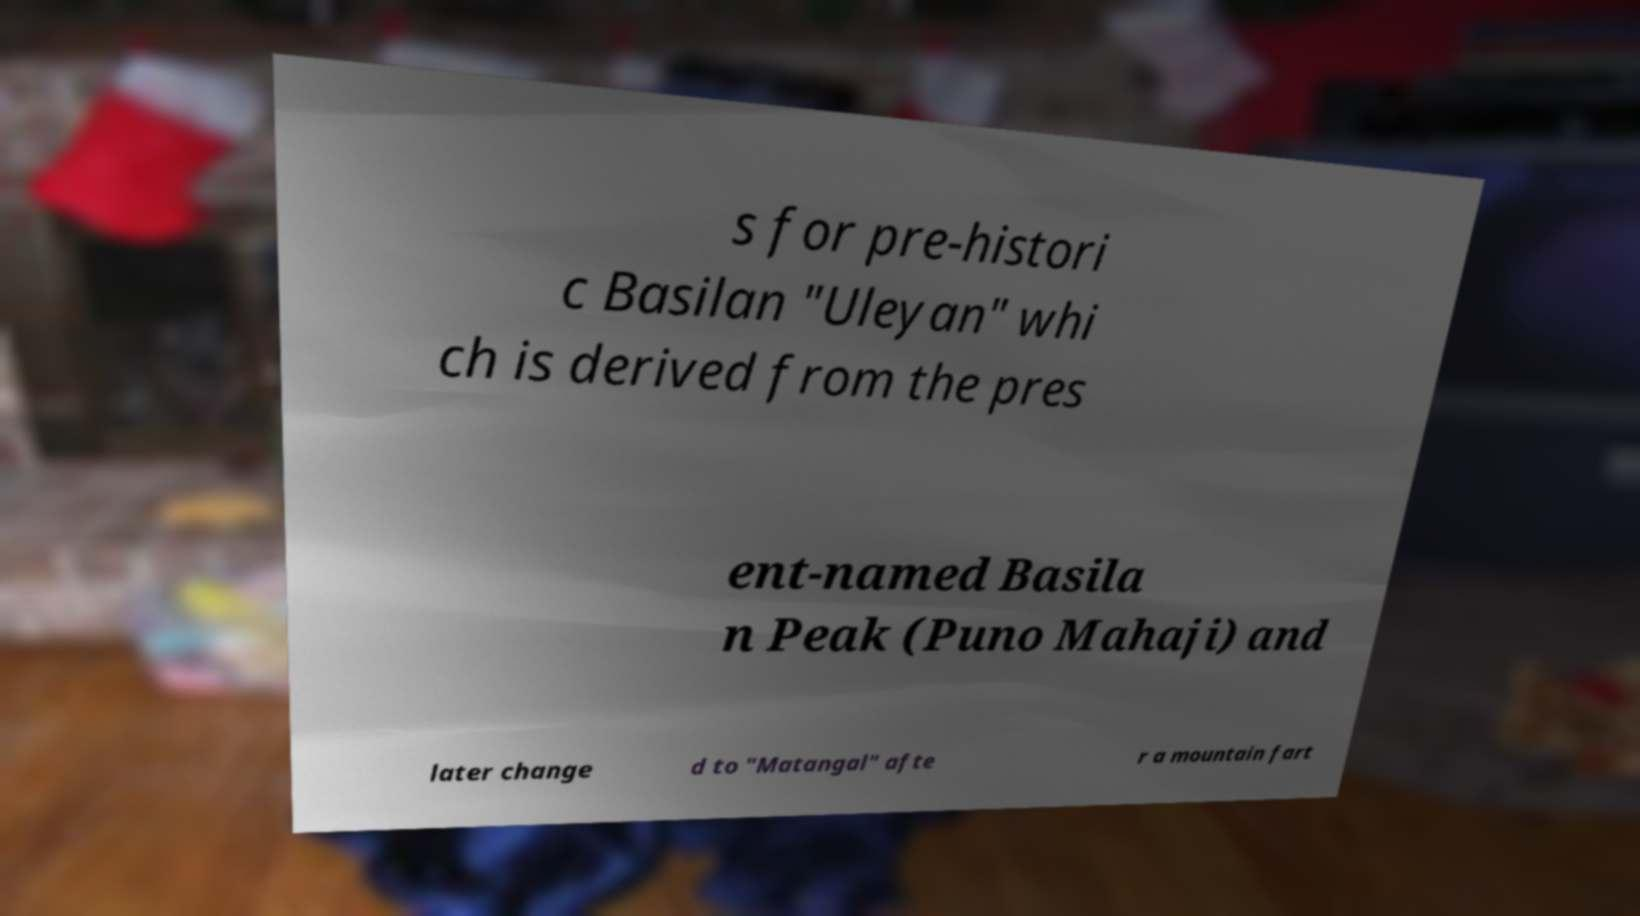Could you assist in decoding the text presented in this image and type it out clearly? s for pre-histori c Basilan "Uleyan" whi ch is derived from the pres ent-named Basila n Peak (Puno Mahaji) and later change d to "Matangal" afte r a mountain fart 